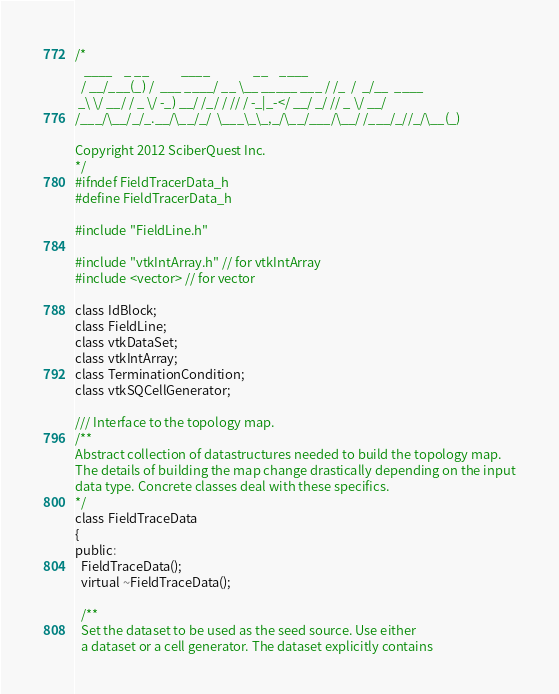Convert code to text. <code><loc_0><loc_0><loc_500><loc_500><_C_>/*
   ____    _ __           ____               __    ____
  / __/___(_) /  ___ ____/ __ \__ _____ ___ / /_  /  _/__  ____
 _\ \/ __/ / _ \/ -_) __/ /_/ / // / -_|_-</ __/ _/ // _ \/ __/
/___/\__/_/_.__/\__/_/  \___\_\_,_/\__/___/\__/ /___/_//_/\__(_)

Copyright 2012 SciberQuest Inc.
*/
#ifndef FieldTracerData_h
#define FieldTracerData_h

#include "FieldLine.h"

#include "vtkIntArray.h" // for vtkIntArray
#include <vector> // for vector

class IdBlock;
class FieldLine;
class vtkDataSet;
class vtkIntArray;
class TerminationCondition;
class vtkSQCellGenerator;

/// Interface to the topology map.
/**
Abstract collection of datastructures needed to build the topology map.
The details of building the map change drastically depending on the input
data type. Concrete classes deal with these specifics.
*/
class FieldTraceData
{
public:
  FieldTraceData();
  virtual ~FieldTraceData();

  /**
  Set the dataset to be used as the seed source. Use either
  a dataset or a cell generator. The dataset explicitly contains</code> 